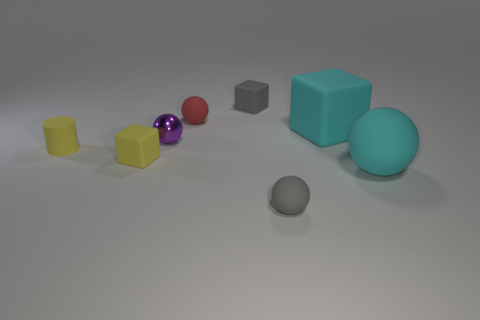Is there any other thing that has the same material as the purple thing?
Your response must be concise. No. What number of blue things are either tiny rubber cylinders or matte blocks?
Your response must be concise. 0. Does the tiny matte cylinder have the same color as the matte cube that is in front of the tiny cylinder?
Offer a terse response. Yes. How many other things are there of the same color as the metal sphere?
Your answer should be compact. 0. Are there fewer small cylinders than large blue matte cubes?
Offer a terse response. No. What number of gray blocks are behind the large cyan rubber sphere in front of the small gray thing that is left of the small gray rubber sphere?
Offer a terse response. 1. What size is the matte cube behind the red rubber thing?
Offer a very short reply. Small. Is the shape of the gray object that is behind the rubber cylinder the same as  the small shiny thing?
Make the answer very short. No. There is a purple object that is the same shape as the red object; what is it made of?
Provide a succinct answer. Metal. Are there any big cyan metallic objects?
Keep it short and to the point. No. 